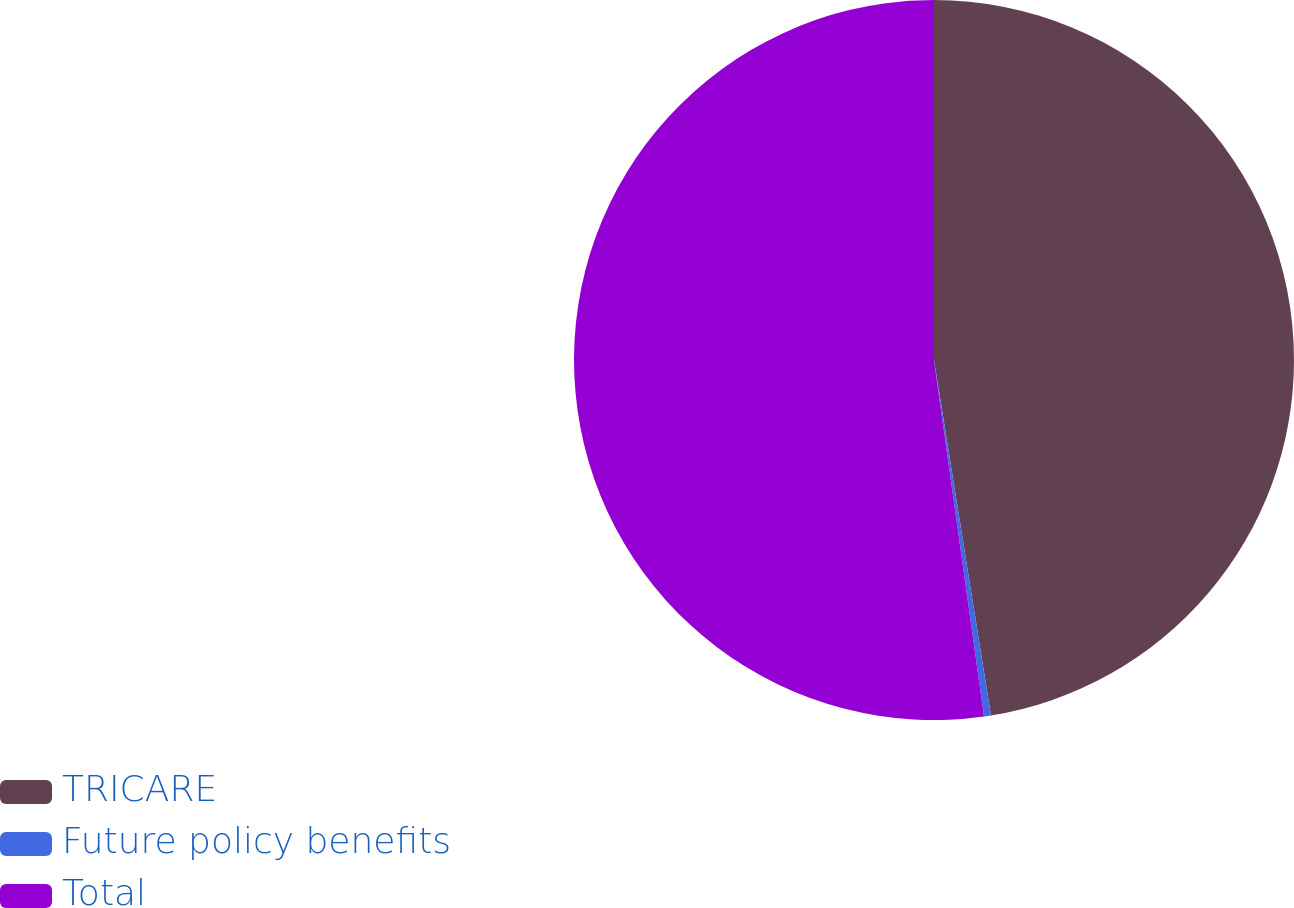<chart> <loc_0><loc_0><loc_500><loc_500><pie_chart><fcel>TRICARE<fcel>Future policy benefits<fcel>Total<nl><fcel>47.47%<fcel>0.31%<fcel>52.22%<nl></chart> 